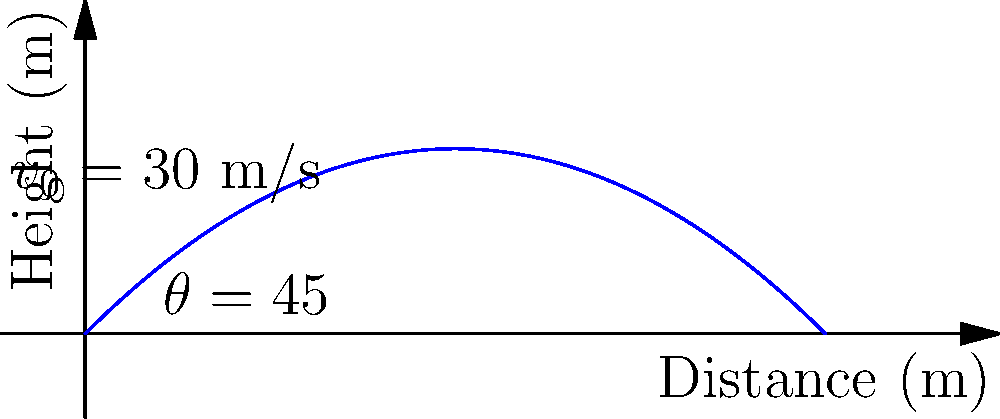In a javelin throwing competition, an athlete launches a javelin with an initial velocity of 30 m/s at an angle of 45° to the horizontal. Assuming air resistance is negligible, what is the maximum height reached by the javelin? To find the maximum height reached by the javelin, we'll follow these steps:

1) The vertical component of the initial velocity is given by:
   $v_{0y} = v_0 \sin \theta = 30 \sin 45° = 30 \cdot \frac{\sqrt{2}}{2} \approx 21.21$ m/s

2) The time to reach the maximum height is when the vertical velocity becomes zero:
   $v_y = v_{0y} - gt = 0$
   $t = \frac{v_{0y}}{g} = \frac{21.21}{9.8} \approx 2.16$ seconds

3) The maximum height is reached at half the total time of flight, so we use $t = 2.16$ s in the equation:
   $h = v_{0y}t - \frac{1}{2}gt^2$

4) Substituting the values:
   $h = 21.21 \cdot 2.16 - \frac{1}{2} \cdot 9.8 \cdot 2.16^2$
   $h = 45.81 - 22.91 = 22.90$ meters

Therefore, the maximum height reached by the javelin is approximately 22.90 meters.
Answer: 22.90 m 